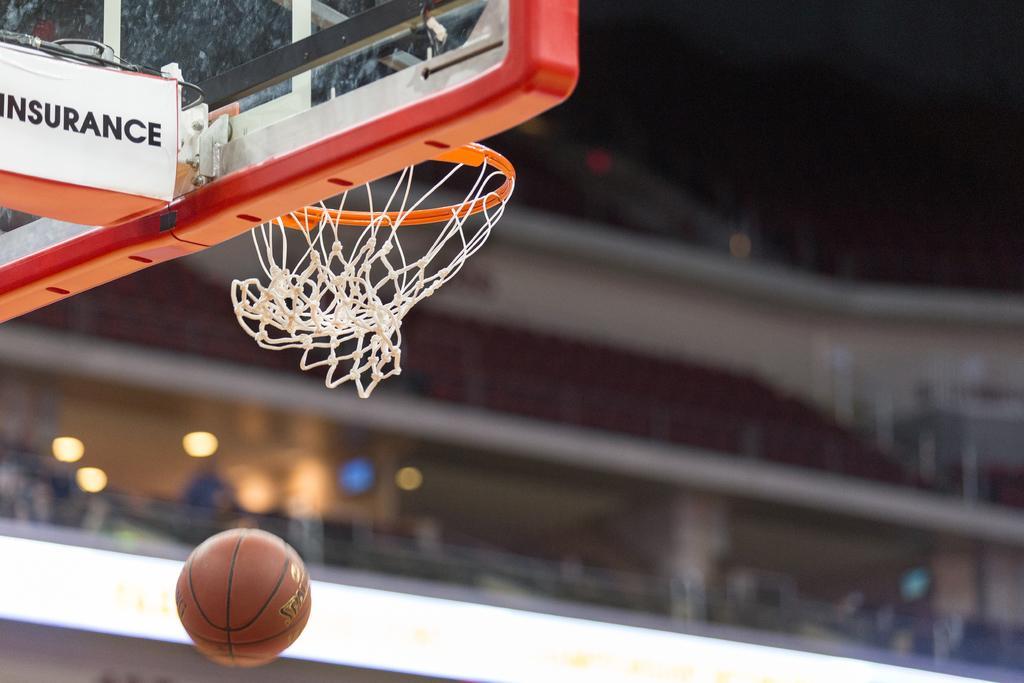Please provide a concise description of this image. In this picture there is a basket board in the top left side of the image and there is a ball at the bottom side of the image. 